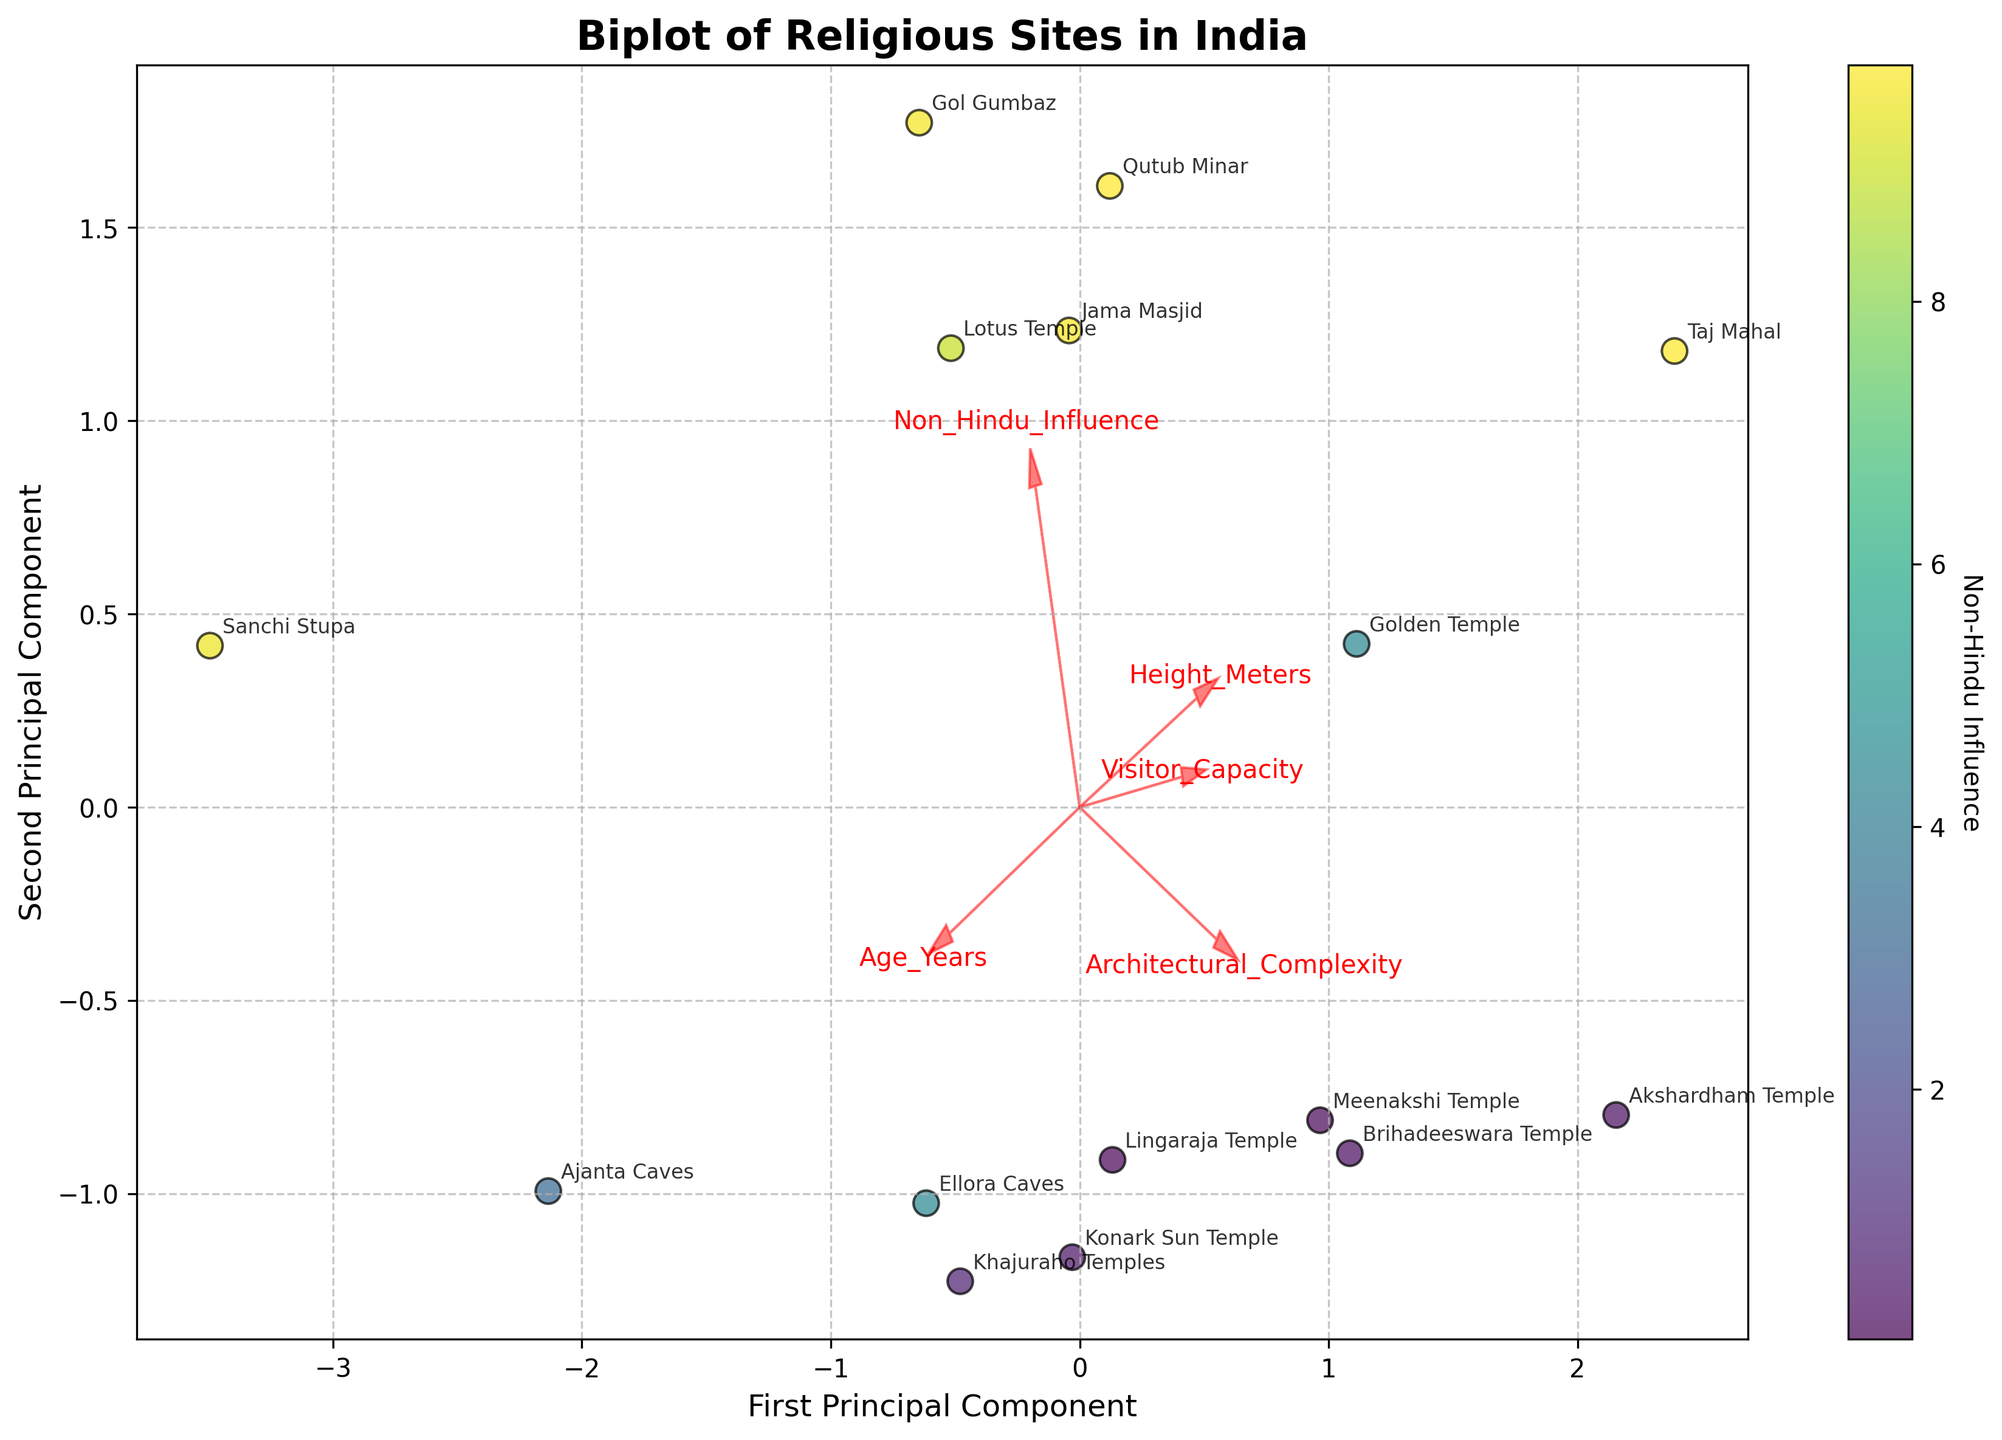What are the axes labeled as in the plot? The x-axis is labeled 'First Principal Component' and the y-axis is labeled 'Second Principal Component.' This indicates the two primary dimensions extracted via PCA.
Answer: First Principal Component, Second Principal Component Which structures are located furthest to the right on the plot? By observing the plot's data points, the 'Akshardham Temple' and 'Meenakshi Temple' are located furthest to the right, indicating a high score on the First Principal Component.
Answer: Akshardham Temple, Meenakshi Temple What is the correlation between Architectural Complexity and the First Principal Component based on vectors? The arrow for Architectural Complexity points strongly to the right on the PCA plot, indicating a positive correlation with the First Principal Component.
Answer: Positive How many sites exhibit a higher Non-Hindu Influence value in the plot? By checking the color intensity (yellowish-green being higher) on the plot, 6 sites (Taj Mahal, Golden Temple, Sanchi Stupa, Jama Masjid, Lotus Temple, and Gol Gumbaz) show a higher Non-Hindu Influence.
Answer: 6 Which site shows the highest visitor capacity in the plot? The scatter plot data and annotations indicate that the 'Golden Temple' has the highest visitor capacity, as denoted in the provided data.
Answer: Golden Temple Which site has influenced both by high Architectural Complexity and significant Non-Hindu Influence? By locating where the Architectural Complexity arrow points and the color representing Non-Hindu Influence, 'Taj Mahal' meets both criteria.
Answer: Taj Mahal How does the height of the Qutub Minar compare to that of the Taj Mahal? The plot shows site annotations and information reveals both 'Qutub Minar' and 'Taj Mahal' have similar heights given in the data (both 73 meters).
Answer: Equal Which features contribute more to the second Principal Component? By observing the directional length and orientation of the arrows, 'Non-Hindu Influence' and 'Visitor Capacity' have significant contributions to the second Principal Component by pointing largely in the vertical direction.
Answer: Non-Hindu Influence, Visitor Capacity Which Hindu site is most influenced by Non-Hindu architectural elements based on the plot? Based on Non-Hindu Influence color gradient and data points, 'Lingaraja Temple' has the highest Non-Hindu Influence for a Hindu site.
Answer: Lingaraja Temple 